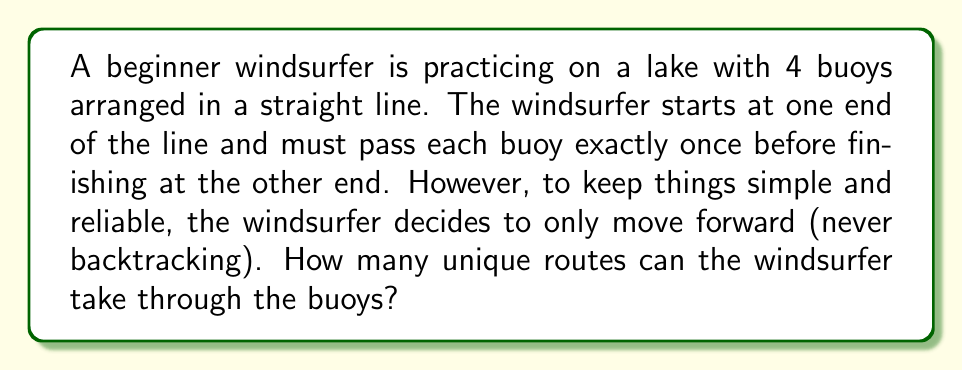Can you solve this math problem? Let's approach this step-by-step:

1) First, we need to understand what the question is asking. The windsurfer must pass all 4 buoys, moving only in one direction (forward).

2) This scenario is equivalent to choosing the order in which to pass the buoys. Since the windsurfer always moves forward, we don't need to consider the starting and ending points separately.

3) We can think of this as arranging 4 distinct objects (the buoys) in a line. This is a classic permutation problem.

4) The number of ways to arrange n distinct objects is given by the formula:

   $$n!$$

   Where $n!$ represents the factorial of n.

5) In this case, we have 4 buoys, so $n = 4$.

6) Therefore, the number of unique routes is:

   $$4! = 4 \times 3 \times 2 \times 1 = 24$$

This means the windsurfer can take 24 different routes through the buoys.

For a beginner windsurfer who values simplicity, it's worth noting that while there are many possible routes, they all involve passing each buoy once in some order, always moving forward. This keeps the task straightforward and reliable, as the windsurfer doesn't need to worry about complex maneuvers or backtracking.
Answer: 24 unique routes 